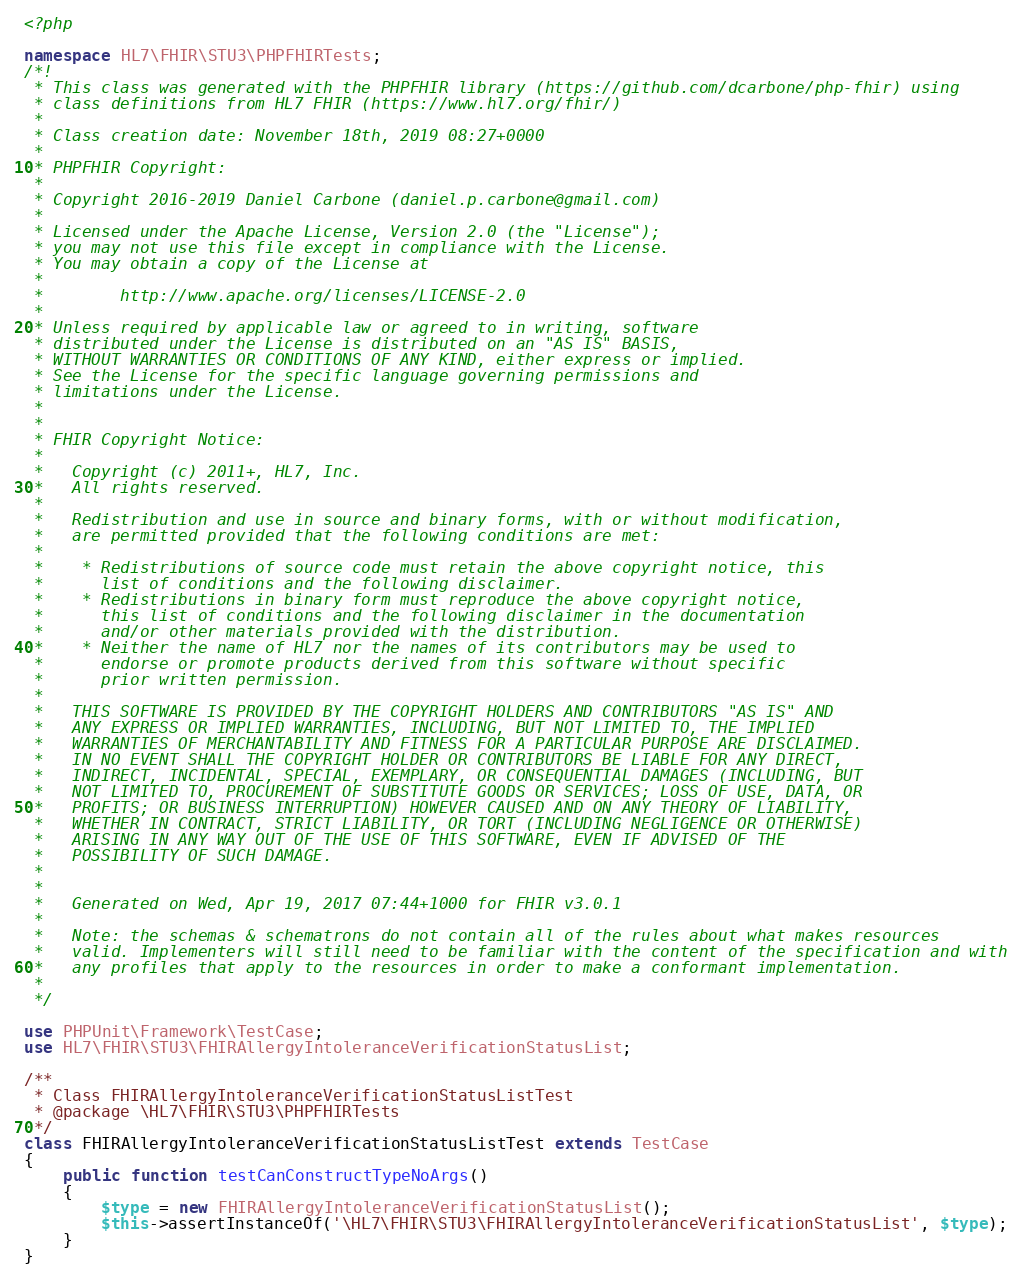<code> <loc_0><loc_0><loc_500><loc_500><_PHP_><?php

namespace HL7\FHIR\STU3\PHPFHIRTests;
/*!
 * This class was generated with the PHPFHIR library (https://github.com/dcarbone/php-fhir) using
 * class definitions from HL7 FHIR (https://www.hl7.org/fhir/)
 * 
 * Class creation date: November 18th, 2019 08:27+0000
 * 
 * PHPFHIR Copyright:
 * 
 * Copyright 2016-2019 Daniel Carbone (daniel.p.carbone@gmail.com)
 * 
 * Licensed under the Apache License, Version 2.0 (the "License");
 * you may not use this file except in compliance with the License.
 * You may obtain a copy of the License at
 * 
 *        http://www.apache.org/licenses/LICENSE-2.0
 * 
 * Unless required by applicable law or agreed to in writing, software
 * distributed under the License is distributed on an "AS IS" BASIS,
 * WITHOUT WARRANTIES OR CONDITIONS OF ANY KIND, either express or implied.
 * See the License for the specific language governing permissions and
 * limitations under the License.
 * 
 *
 * FHIR Copyright Notice:
 *
 *   Copyright (c) 2011+, HL7, Inc.
 *   All rights reserved.
 * 
 *   Redistribution and use in source and binary forms, with or without modification,
 *   are permitted provided that the following conditions are met:
 * 
 *    * Redistributions of source code must retain the above copyright notice, this
 *      list of conditions and the following disclaimer.
 *    * Redistributions in binary form must reproduce the above copyright notice,
 *      this list of conditions and the following disclaimer in the documentation
 *      and/or other materials provided with the distribution.
 *    * Neither the name of HL7 nor the names of its contributors may be used to
 *      endorse or promote products derived from this software without specific
 *      prior written permission.
 * 
 *   THIS SOFTWARE IS PROVIDED BY THE COPYRIGHT HOLDERS AND CONTRIBUTORS "AS IS" AND
 *   ANY EXPRESS OR IMPLIED WARRANTIES, INCLUDING, BUT NOT LIMITED TO, THE IMPLIED
 *   WARRANTIES OF MERCHANTABILITY AND FITNESS FOR A PARTICULAR PURPOSE ARE DISCLAIMED.
 *   IN NO EVENT SHALL THE COPYRIGHT HOLDER OR CONTRIBUTORS BE LIABLE FOR ANY DIRECT,
 *   INDIRECT, INCIDENTAL, SPECIAL, EXEMPLARY, OR CONSEQUENTIAL DAMAGES (INCLUDING, BUT
 *   NOT LIMITED TO, PROCUREMENT OF SUBSTITUTE GOODS OR SERVICES; LOSS OF USE, DATA, OR
 *   PROFITS; OR BUSINESS INTERRUPTION) HOWEVER CAUSED AND ON ANY THEORY OF LIABILITY,
 *   WHETHER IN CONTRACT, STRICT LIABILITY, OR TORT (INCLUDING NEGLIGENCE OR OTHERWISE)
 *   ARISING IN ANY WAY OUT OF THE USE OF THIS SOFTWARE, EVEN IF ADVISED OF THE
 *   POSSIBILITY OF SUCH DAMAGE.
 * 
 * 
 *   Generated on Wed, Apr 19, 2017 07:44+1000 for FHIR v3.0.1
 * 
 *   Note: the schemas & schematrons do not contain all of the rules about what makes resources
 *   valid. Implementers will still need to be familiar with the content of the specification and with
 *   any profiles that apply to the resources in order to make a conformant implementation.
 * 
 */

use PHPUnit\Framework\TestCase;
use HL7\FHIR\STU3\FHIRAllergyIntoleranceVerificationStatusList;

/**
 * Class FHIRAllergyIntoleranceVerificationStatusListTest
 * @package \HL7\FHIR\STU3\PHPFHIRTests
 */
class FHIRAllergyIntoleranceVerificationStatusListTest extends TestCase
{
    public function testCanConstructTypeNoArgs()
    {
        $type = new FHIRAllergyIntoleranceVerificationStatusList();
        $this->assertInstanceOf('\HL7\FHIR\STU3\FHIRAllergyIntoleranceVerificationStatusList', $type);
    }
}
</code> 